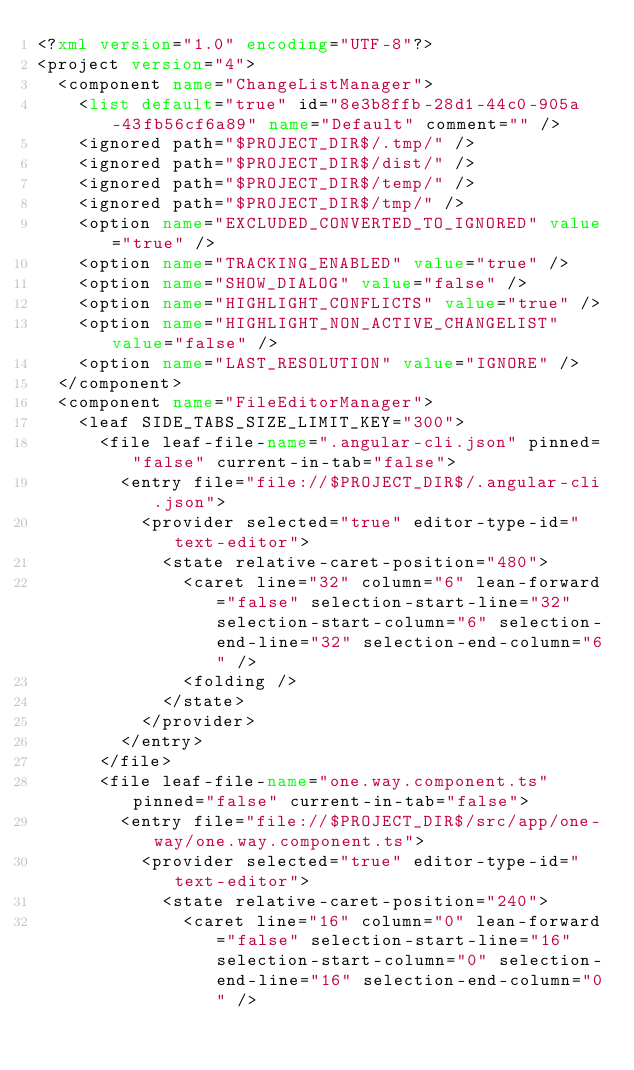<code> <loc_0><loc_0><loc_500><loc_500><_XML_><?xml version="1.0" encoding="UTF-8"?>
<project version="4">
  <component name="ChangeListManager">
    <list default="true" id="8e3b8ffb-28d1-44c0-905a-43fb56cf6a89" name="Default" comment="" />
    <ignored path="$PROJECT_DIR$/.tmp/" />
    <ignored path="$PROJECT_DIR$/dist/" />
    <ignored path="$PROJECT_DIR$/temp/" />
    <ignored path="$PROJECT_DIR$/tmp/" />
    <option name="EXCLUDED_CONVERTED_TO_IGNORED" value="true" />
    <option name="TRACKING_ENABLED" value="true" />
    <option name="SHOW_DIALOG" value="false" />
    <option name="HIGHLIGHT_CONFLICTS" value="true" />
    <option name="HIGHLIGHT_NON_ACTIVE_CHANGELIST" value="false" />
    <option name="LAST_RESOLUTION" value="IGNORE" />
  </component>
  <component name="FileEditorManager">
    <leaf SIDE_TABS_SIZE_LIMIT_KEY="300">
      <file leaf-file-name=".angular-cli.json" pinned="false" current-in-tab="false">
        <entry file="file://$PROJECT_DIR$/.angular-cli.json">
          <provider selected="true" editor-type-id="text-editor">
            <state relative-caret-position="480">
              <caret line="32" column="6" lean-forward="false" selection-start-line="32" selection-start-column="6" selection-end-line="32" selection-end-column="6" />
              <folding />
            </state>
          </provider>
        </entry>
      </file>
      <file leaf-file-name="one.way.component.ts" pinned="false" current-in-tab="false">
        <entry file="file://$PROJECT_DIR$/src/app/one-way/one.way.component.ts">
          <provider selected="true" editor-type-id="text-editor">
            <state relative-caret-position="240">
              <caret line="16" column="0" lean-forward="false" selection-start-line="16" selection-start-column="0" selection-end-line="16" selection-end-column="0" /></code> 